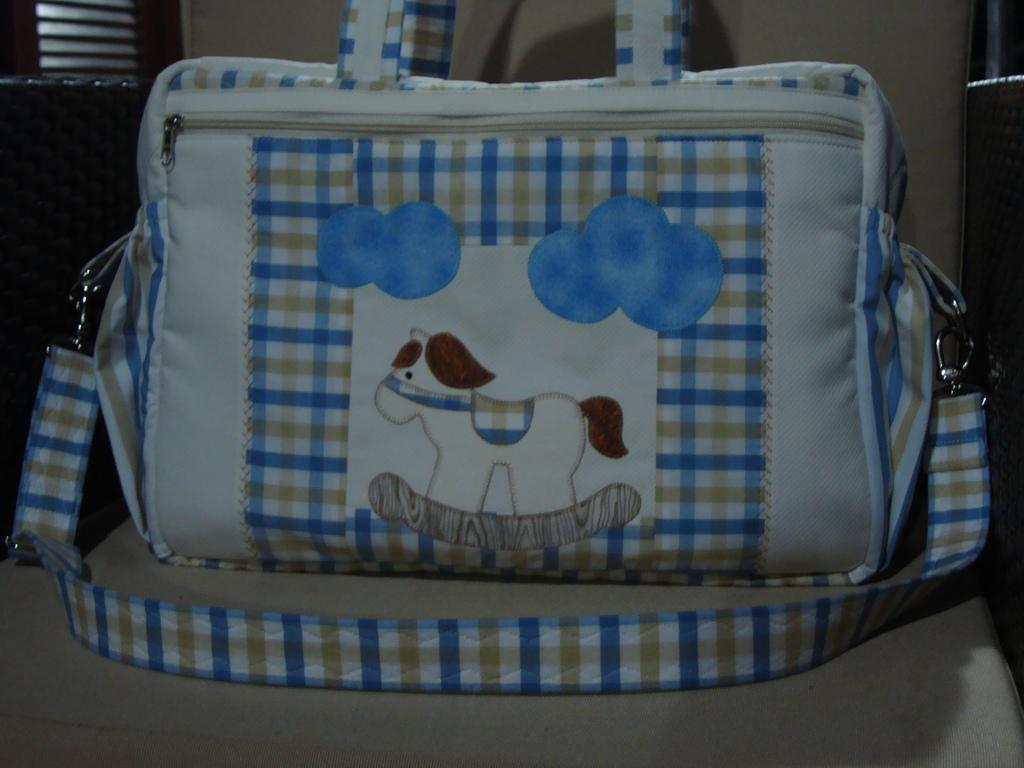What is present in the image that can be used to carry items? There is a bag in the image. What design is featured on the bag? The bag has dog shape art on it. Where is the bag located in the image? The bag is on a sofa. What type of education can be seen being taught in the image? There is no education or teaching activity present in the image; it features a bag with dog shape art on a sofa. 